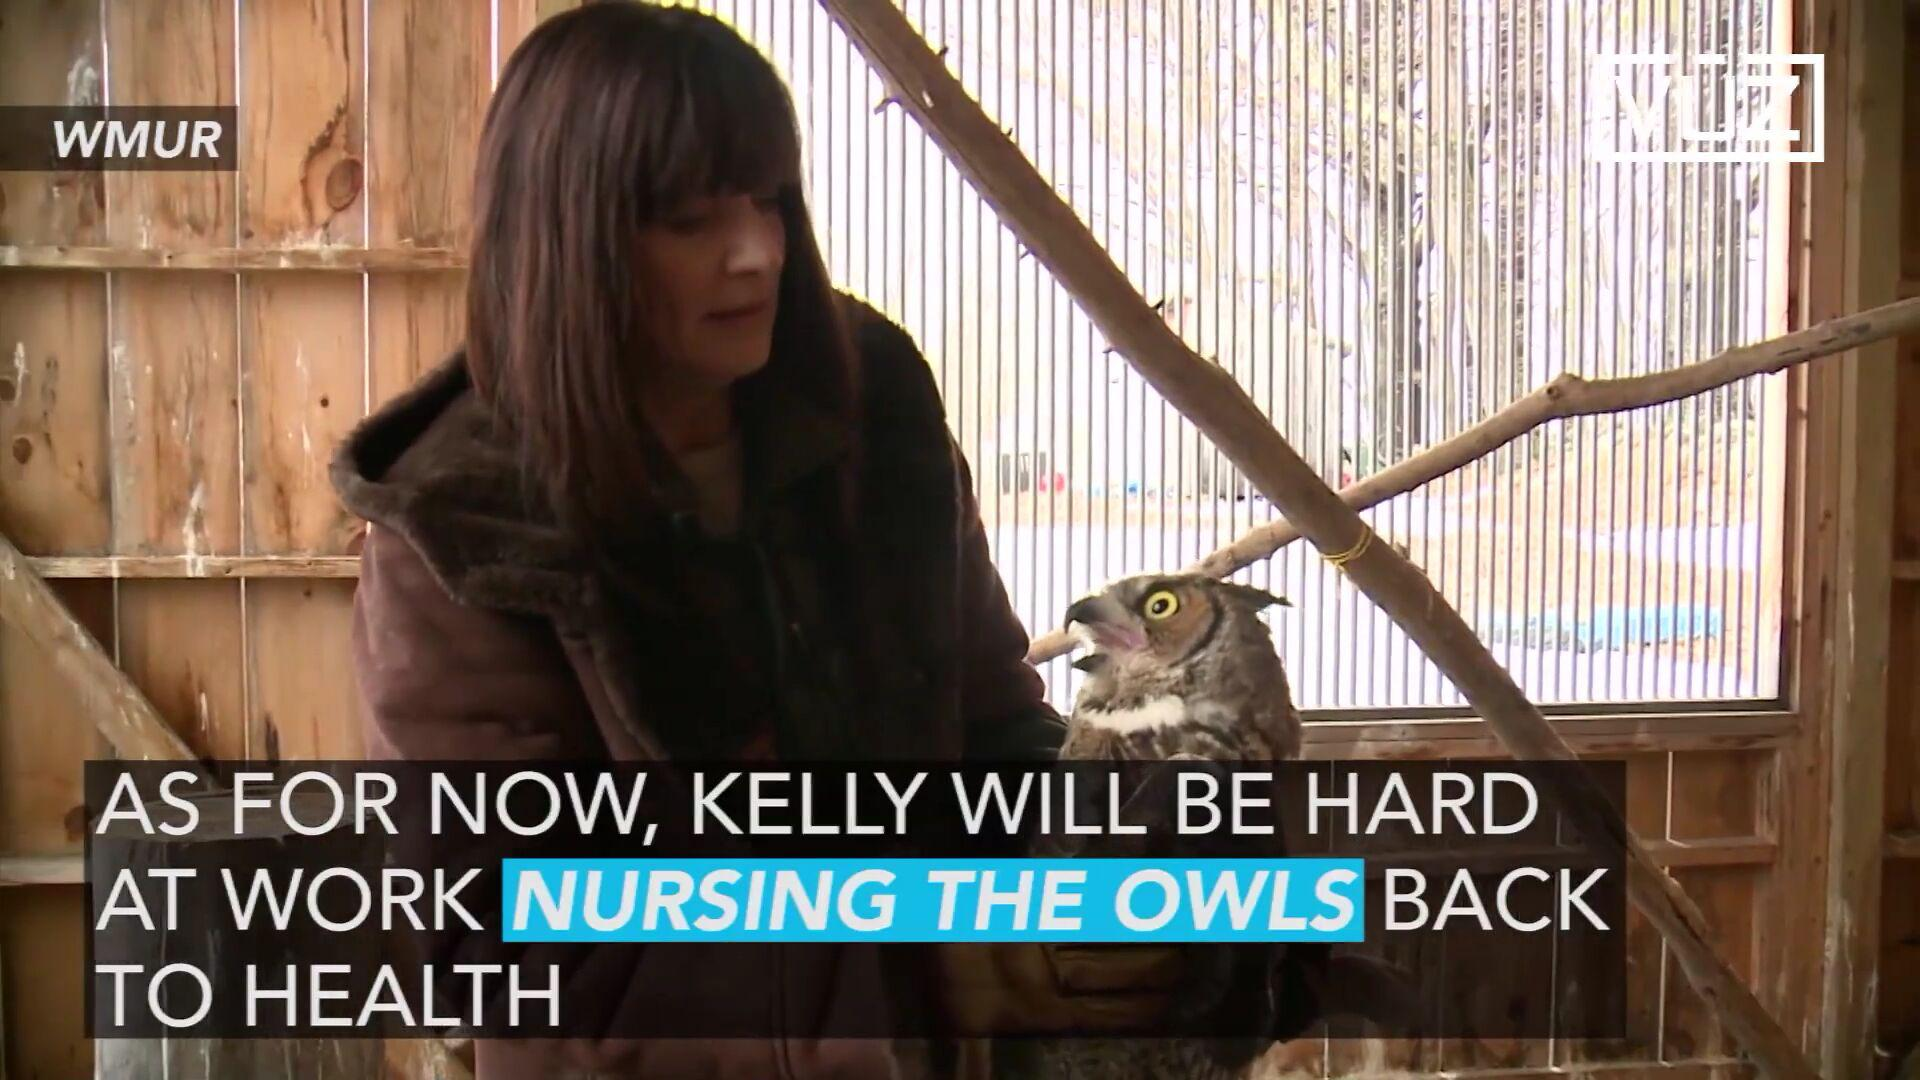Which option is highlighted in red? The highlighted option in red is "Enable location". 